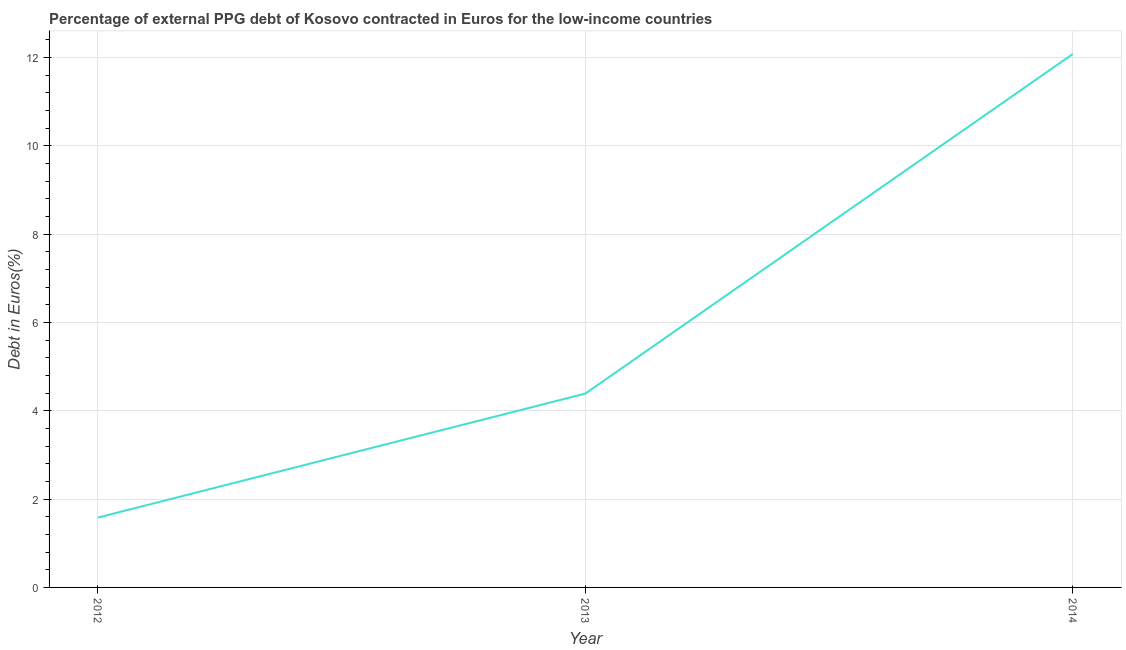What is the currency composition of ppg debt in 2014?
Offer a terse response. 12.08. Across all years, what is the maximum currency composition of ppg debt?
Give a very brief answer. 12.08. Across all years, what is the minimum currency composition of ppg debt?
Ensure brevity in your answer.  1.58. In which year was the currency composition of ppg debt maximum?
Provide a succinct answer. 2014. In which year was the currency composition of ppg debt minimum?
Your response must be concise. 2012. What is the sum of the currency composition of ppg debt?
Offer a terse response. 18.05. What is the difference between the currency composition of ppg debt in 2013 and 2014?
Your answer should be very brief. -7.69. What is the average currency composition of ppg debt per year?
Your response must be concise. 6.02. What is the median currency composition of ppg debt?
Keep it short and to the point. 4.39. Do a majority of the years between 2012 and 2014 (inclusive) have currency composition of ppg debt greater than 2.8 %?
Your answer should be compact. Yes. What is the ratio of the currency composition of ppg debt in 2012 to that in 2014?
Provide a succinct answer. 0.13. What is the difference between the highest and the second highest currency composition of ppg debt?
Keep it short and to the point. 7.69. What is the difference between the highest and the lowest currency composition of ppg debt?
Give a very brief answer. 10.5. Does the currency composition of ppg debt monotonically increase over the years?
Ensure brevity in your answer.  Yes. Does the graph contain any zero values?
Ensure brevity in your answer.  No. Does the graph contain grids?
Your response must be concise. Yes. What is the title of the graph?
Your answer should be compact. Percentage of external PPG debt of Kosovo contracted in Euros for the low-income countries. What is the label or title of the Y-axis?
Your answer should be very brief. Debt in Euros(%). What is the Debt in Euros(%) in 2012?
Ensure brevity in your answer.  1.58. What is the Debt in Euros(%) in 2013?
Your answer should be compact. 4.39. What is the Debt in Euros(%) in 2014?
Make the answer very short. 12.08. What is the difference between the Debt in Euros(%) in 2012 and 2013?
Your answer should be very brief. -2.81. What is the difference between the Debt in Euros(%) in 2012 and 2014?
Your answer should be compact. -10.5. What is the difference between the Debt in Euros(%) in 2013 and 2014?
Your answer should be very brief. -7.69. What is the ratio of the Debt in Euros(%) in 2012 to that in 2013?
Offer a terse response. 0.36. What is the ratio of the Debt in Euros(%) in 2012 to that in 2014?
Your answer should be very brief. 0.13. What is the ratio of the Debt in Euros(%) in 2013 to that in 2014?
Your answer should be very brief. 0.36. 